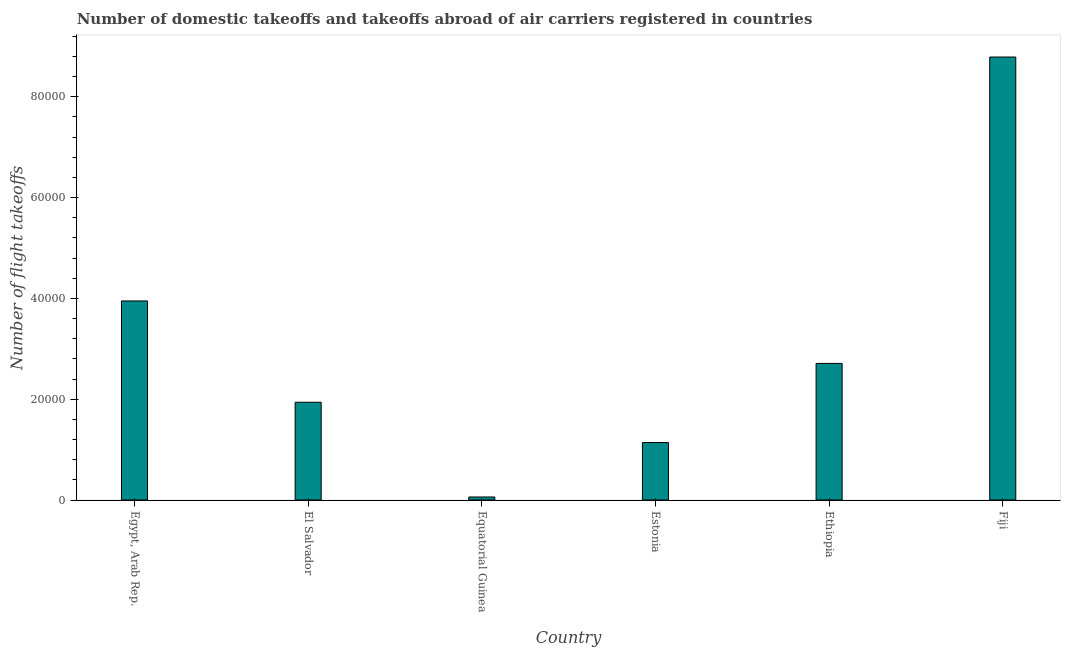Does the graph contain grids?
Ensure brevity in your answer.  No. What is the title of the graph?
Your answer should be very brief. Number of domestic takeoffs and takeoffs abroad of air carriers registered in countries. What is the label or title of the Y-axis?
Make the answer very short. Number of flight takeoffs. What is the number of flight takeoffs in Equatorial Guinea?
Keep it short and to the point. 600. Across all countries, what is the maximum number of flight takeoffs?
Your response must be concise. 8.79e+04. Across all countries, what is the minimum number of flight takeoffs?
Provide a short and direct response. 600. In which country was the number of flight takeoffs maximum?
Give a very brief answer. Fiji. In which country was the number of flight takeoffs minimum?
Ensure brevity in your answer.  Equatorial Guinea. What is the sum of the number of flight takeoffs?
Offer a very short reply. 1.86e+05. What is the difference between the number of flight takeoffs in Ethiopia and Fiji?
Your answer should be compact. -6.08e+04. What is the average number of flight takeoffs per country?
Your response must be concise. 3.10e+04. What is the median number of flight takeoffs?
Keep it short and to the point. 2.32e+04. In how many countries, is the number of flight takeoffs greater than 16000 ?
Offer a very short reply. 4. What is the ratio of the number of flight takeoffs in Egypt, Arab Rep. to that in El Salvador?
Provide a short and direct response. 2.04. What is the difference between the highest and the second highest number of flight takeoffs?
Your answer should be very brief. 4.84e+04. What is the difference between the highest and the lowest number of flight takeoffs?
Ensure brevity in your answer.  8.73e+04. In how many countries, is the number of flight takeoffs greater than the average number of flight takeoffs taken over all countries?
Keep it short and to the point. 2. How many bars are there?
Provide a succinct answer. 6. Are all the bars in the graph horizontal?
Your answer should be very brief. No. How many countries are there in the graph?
Your answer should be compact. 6. Are the values on the major ticks of Y-axis written in scientific E-notation?
Your answer should be very brief. No. What is the Number of flight takeoffs in Egypt, Arab Rep.?
Keep it short and to the point. 3.95e+04. What is the Number of flight takeoffs in El Salvador?
Your answer should be compact. 1.94e+04. What is the Number of flight takeoffs in Equatorial Guinea?
Your answer should be very brief. 600. What is the Number of flight takeoffs of Estonia?
Make the answer very short. 1.14e+04. What is the Number of flight takeoffs of Ethiopia?
Your answer should be compact. 2.71e+04. What is the Number of flight takeoffs in Fiji?
Your response must be concise. 8.79e+04. What is the difference between the Number of flight takeoffs in Egypt, Arab Rep. and El Salvador?
Make the answer very short. 2.01e+04. What is the difference between the Number of flight takeoffs in Egypt, Arab Rep. and Equatorial Guinea?
Make the answer very short. 3.89e+04. What is the difference between the Number of flight takeoffs in Egypt, Arab Rep. and Estonia?
Offer a terse response. 2.81e+04. What is the difference between the Number of flight takeoffs in Egypt, Arab Rep. and Ethiopia?
Provide a short and direct response. 1.24e+04. What is the difference between the Number of flight takeoffs in Egypt, Arab Rep. and Fiji?
Your answer should be very brief. -4.84e+04. What is the difference between the Number of flight takeoffs in El Salvador and Equatorial Guinea?
Provide a short and direct response. 1.88e+04. What is the difference between the Number of flight takeoffs in El Salvador and Estonia?
Offer a terse response. 8000. What is the difference between the Number of flight takeoffs in El Salvador and Ethiopia?
Your answer should be very brief. -7700. What is the difference between the Number of flight takeoffs in El Salvador and Fiji?
Provide a short and direct response. -6.85e+04. What is the difference between the Number of flight takeoffs in Equatorial Guinea and Estonia?
Offer a terse response. -1.08e+04. What is the difference between the Number of flight takeoffs in Equatorial Guinea and Ethiopia?
Make the answer very short. -2.65e+04. What is the difference between the Number of flight takeoffs in Equatorial Guinea and Fiji?
Keep it short and to the point. -8.73e+04. What is the difference between the Number of flight takeoffs in Estonia and Ethiopia?
Your answer should be very brief. -1.57e+04. What is the difference between the Number of flight takeoffs in Estonia and Fiji?
Keep it short and to the point. -7.65e+04. What is the difference between the Number of flight takeoffs in Ethiopia and Fiji?
Provide a succinct answer. -6.08e+04. What is the ratio of the Number of flight takeoffs in Egypt, Arab Rep. to that in El Salvador?
Offer a very short reply. 2.04. What is the ratio of the Number of flight takeoffs in Egypt, Arab Rep. to that in Equatorial Guinea?
Ensure brevity in your answer.  65.83. What is the ratio of the Number of flight takeoffs in Egypt, Arab Rep. to that in Estonia?
Offer a very short reply. 3.46. What is the ratio of the Number of flight takeoffs in Egypt, Arab Rep. to that in Ethiopia?
Provide a short and direct response. 1.46. What is the ratio of the Number of flight takeoffs in Egypt, Arab Rep. to that in Fiji?
Make the answer very short. 0.45. What is the ratio of the Number of flight takeoffs in El Salvador to that in Equatorial Guinea?
Ensure brevity in your answer.  32.33. What is the ratio of the Number of flight takeoffs in El Salvador to that in Estonia?
Give a very brief answer. 1.7. What is the ratio of the Number of flight takeoffs in El Salvador to that in Ethiopia?
Provide a short and direct response. 0.72. What is the ratio of the Number of flight takeoffs in El Salvador to that in Fiji?
Your answer should be compact. 0.22. What is the ratio of the Number of flight takeoffs in Equatorial Guinea to that in Estonia?
Keep it short and to the point. 0.05. What is the ratio of the Number of flight takeoffs in Equatorial Guinea to that in Ethiopia?
Ensure brevity in your answer.  0.02. What is the ratio of the Number of flight takeoffs in Equatorial Guinea to that in Fiji?
Offer a terse response. 0.01. What is the ratio of the Number of flight takeoffs in Estonia to that in Ethiopia?
Provide a short and direct response. 0.42. What is the ratio of the Number of flight takeoffs in Estonia to that in Fiji?
Your response must be concise. 0.13. What is the ratio of the Number of flight takeoffs in Ethiopia to that in Fiji?
Keep it short and to the point. 0.31. 